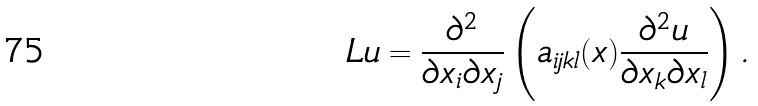Convert formula to latex. <formula><loc_0><loc_0><loc_500><loc_500>L u = \frac { \partial ^ { 2 } } { \partial x _ { i } \partial x _ { j } } \left ( a _ { i j k l } ( x ) \frac { \partial ^ { 2 } u } { \partial x _ { k } \partial x _ { l } } \right ) .</formula> 